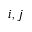Convert formula to latex. <formula><loc_0><loc_0><loc_500><loc_500>i , j</formula> 